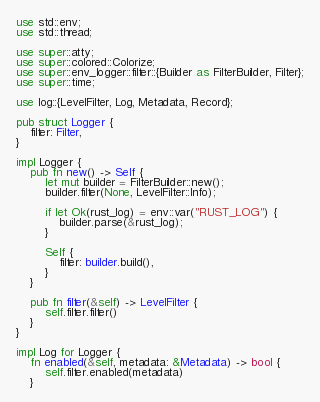<code> <loc_0><loc_0><loc_500><loc_500><_Rust_>use std::env;
use std::thread;

use super::atty;
use super::colored::Colorize;
use super::env_logger::filter::{Builder as FilterBuilder, Filter};
use super::time;

use log::{LevelFilter, Log, Metadata, Record};

pub struct Logger {
    filter: Filter,
}

impl Logger {
    pub fn new() -> Self {
        let mut builder = FilterBuilder::new();
        builder.filter(None, LevelFilter::Info);

        if let Ok(rust_log) = env::var("RUST_LOG") {
            builder.parse(&rust_log);
        }

        Self {
            filter: builder.build(),
        }
    }

    pub fn filter(&self) -> LevelFilter {
        self.filter.filter()
    }
}

impl Log for Logger {
    fn enabled(&self, metadata: &Metadata) -> bool {
        self.filter.enabled(metadata)
    }
</code> 